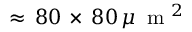<formula> <loc_0><loc_0><loc_500><loc_500>\approx \, 8 0 \, \times \, 8 0 \, \mu \, m ^ { 2 }</formula> 